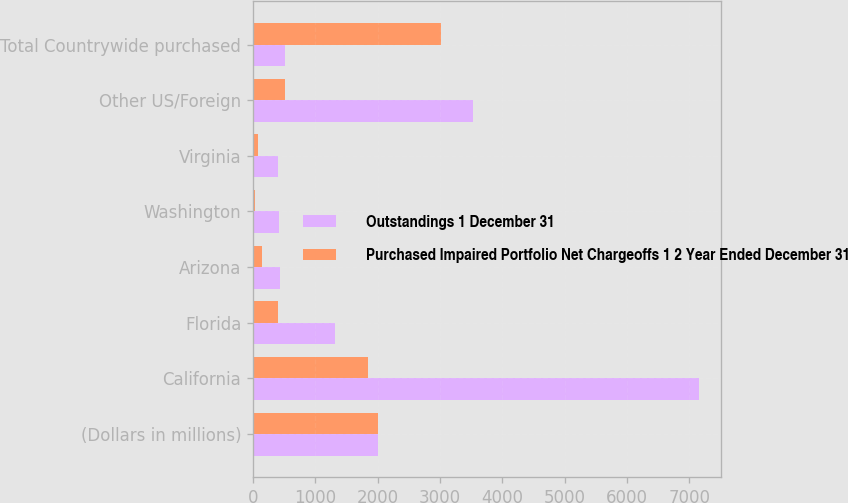Convert chart to OTSL. <chart><loc_0><loc_0><loc_500><loc_500><stacked_bar_chart><ecel><fcel>(Dollars in millions)<fcel>California<fcel>Florida<fcel>Arizona<fcel>Washington<fcel>Virginia<fcel>Other US/Foreign<fcel>Total Countrywide purchased<nl><fcel>Outstandings 1 December 31<fcel>2009<fcel>7148<fcel>1315<fcel>430<fcel>421<fcel>399<fcel>3537<fcel>517<nl><fcel>Purchased Impaired Portfolio Net Chargeoffs 1 2 Year Ended December 31<fcel>2009<fcel>1845<fcel>393<fcel>151<fcel>30<fcel>76<fcel>517<fcel>3012<nl></chart> 